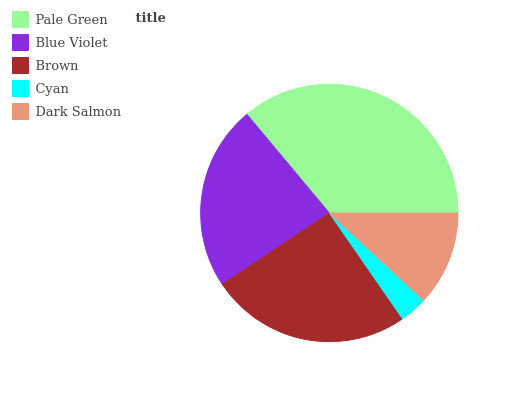Is Cyan the minimum?
Answer yes or no. Yes. Is Pale Green the maximum?
Answer yes or no. Yes. Is Blue Violet the minimum?
Answer yes or no. No. Is Blue Violet the maximum?
Answer yes or no. No. Is Pale Green greater than Blue Violet?
Answer yes or no. Yes. Is Blue Violet less than Pale Green?
Answer yes or no. Yes. Is Blue Violet greater than Pale Green?
Answer yes or no. No. Is Pale Green less than Blue Violet?
Answer yes or no. No. Is Blue Violet the high median?
Answer yes or no. Yes. Is Blue Violet the low median?
Answer yes or no. Yes. Is Cyan the high median?
Answer yes or no. No. Is Cyan the low median?
Answer yes or no. No. 